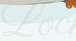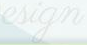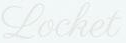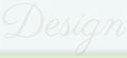Transcribe the words shown in these images in order, separated by a semicolon. Loc; esign; Locket; Design 